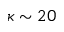Convert formula to latex. <formula><loc_0><loc_0><loc_500><loc_500>\kappa \sim 2 0</formula> 